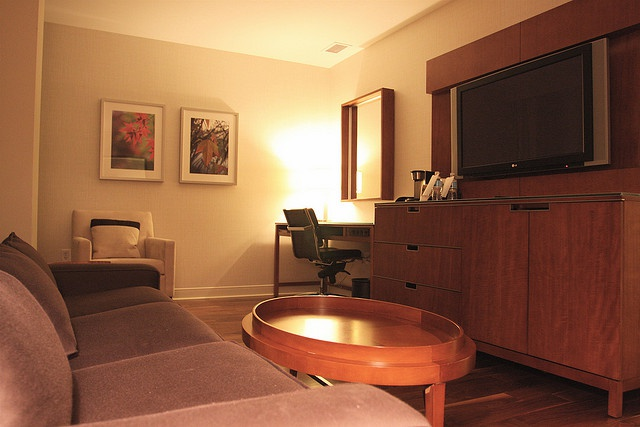Describe the objects in this image and their specific colors. I can see couch in brown, maroon, and salmon tones, tv in brown, black, and maroon tones, couch in brown, salmon, tan, and maroon tones, chair in brown, salmon, tan, and maroon tones, and chair in brown, black, maroon, and gray tones in this image. 